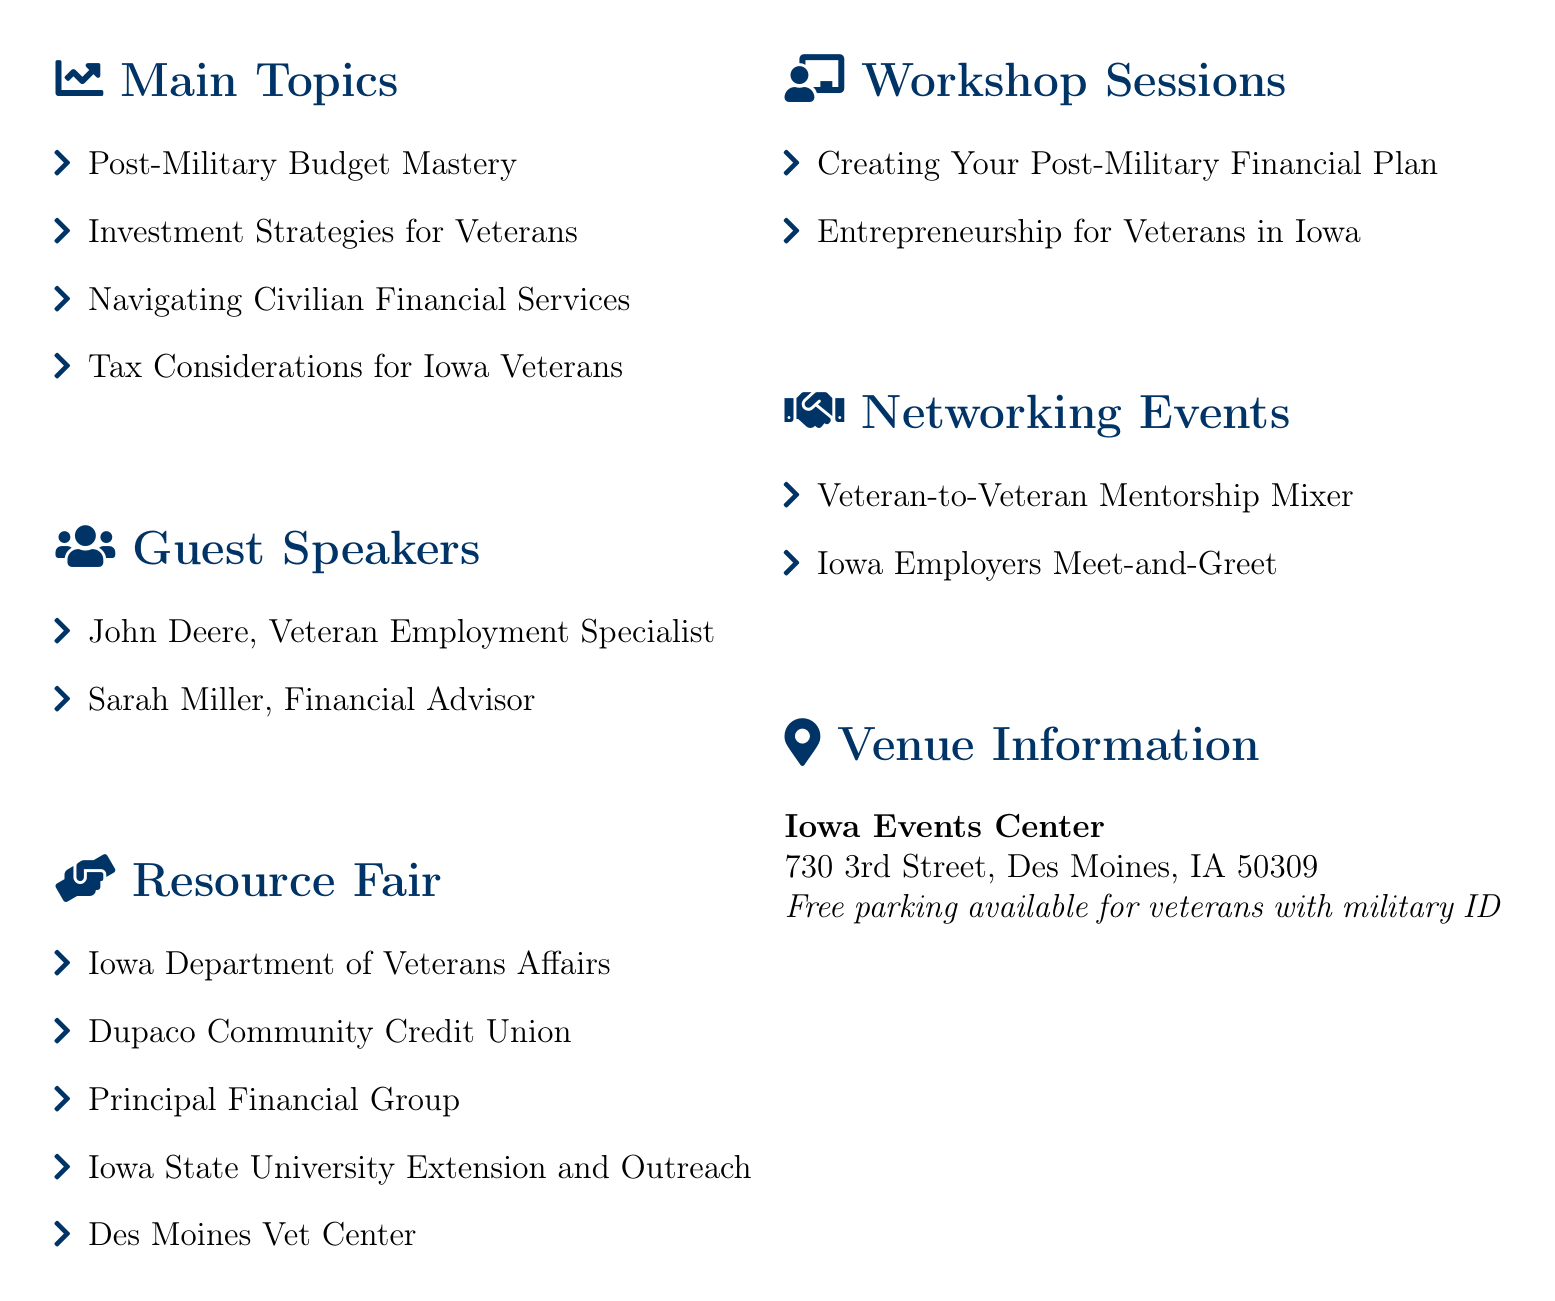What is the title of the seminar? The title of the seminar is explicitly stated at the beginning of the document as "Financial Freedom After Service: Budgeting and Investing for Iowa Veterans."
Answer: Financial Freedom After Service: Budgeting and Investing for Iowa Veterans Who is the guest speaker representing Iowa Workforce Development? The document lists John Deere as the Veteran Employment Specialist from Iowa Workforce Development as a guest speaker.
Answer: John Deere What is one of the subtopics under "Post-Military Budget Mastery"? The document lists several subtopics, one of which is "Creating a zero-based budget."
Answer: Creating a zero-based budget How many workshop sessions are mentioned in the document? The document provides two workshop sessions, indicating the total number mentioned is two.
Answer: 2 What is the venue for the seminar? The venue information clearly states that the event will be held at the "Iowa Events Center."
Answer: Iowa Events Center What type of networking event focuses on connecting veterans? One networking event specifically targets veterans looking to connect called the "Veteran-to-Veteran Mentorship Mixer."
Answer: Veteran-to-Veteran Mentorship Mixer What is a resource available at the resource fair? The document lists multiple resources, one being the "Dupaco Community Credit Union."
Answer: Dupaco Community Credit Union What specific financial service is a subtopic under "Navigating Civilian Financial Services"? The document includes "Understanding civilian credit scores" as a subtopic under the given main topic.
Answer: Understanding civilian credit scores What is the parking policy for veterans at the venue? The venue information states that there is "Free parking available for veterans with military ID."
Answer: Free parking available for veterans with military ID 